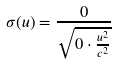<formula> <loc_0><loc_0><loc_500><loc_500>\sigma ( u ) = \frac { 0 } { \sqrt { 0 \cdot \frac { u ^ { 2 } } { c ^ { 2 } } } }</formula> 